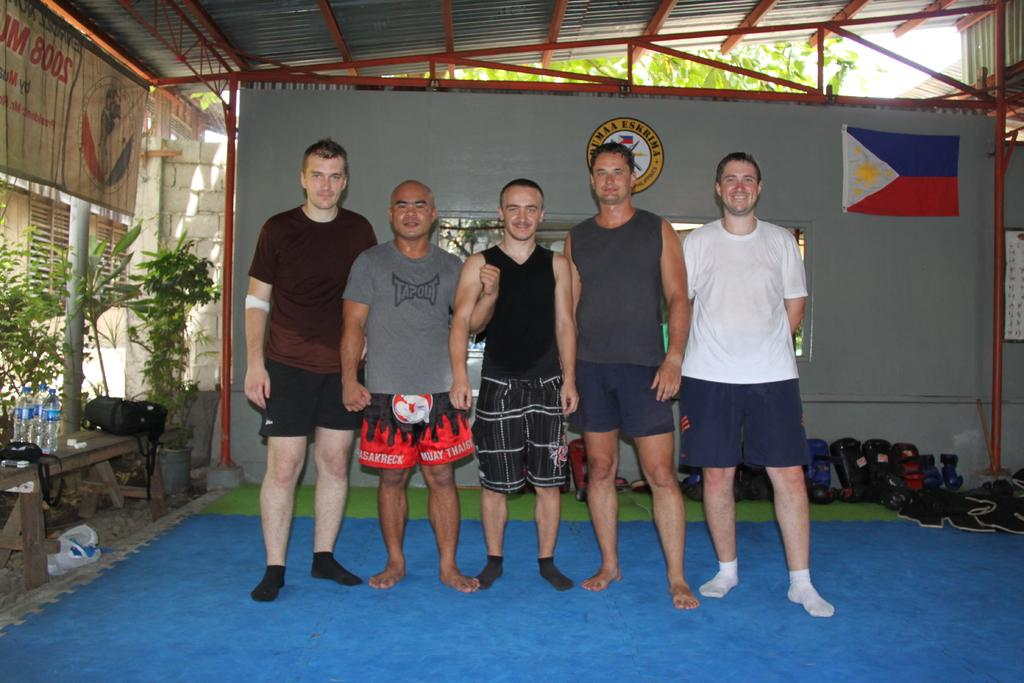Provide a one-sentence caption for the provided image. Five men posing and one has a Tapout shirt on. 